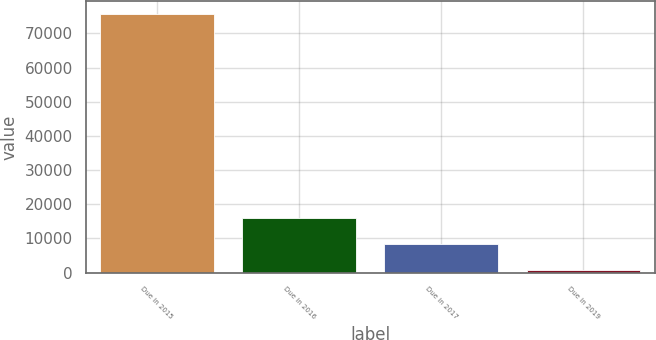<chart> <loc_0><loc_0><loc_500><loc_500><bar_chart><fcel>Due in 2015<fcel>Due in 2016<fcel>Due in 2017<fcel>Due in 2019<nl><fcel>75604<fcel>15812.8<fcel>8338.9<fcel>865<nl></chart> 